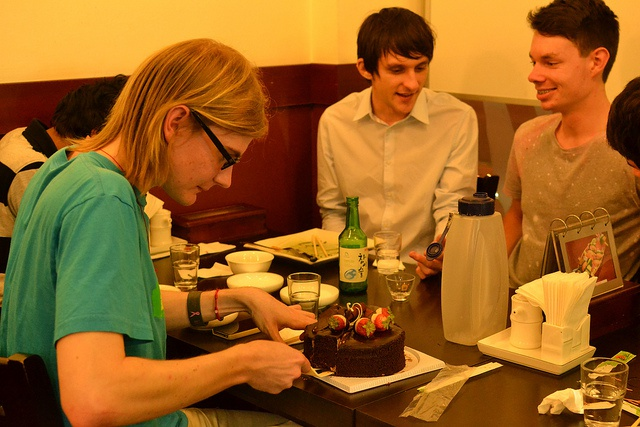Describe the objects in this image and their specific colors. I can see people in orange, brown, red, and green tones, people in orange, red, black, and maroon tones, people in orange, red, and black tones, dining table in orange, maroon, black, and olive tones, and bottle in orange and black tones in this image. 